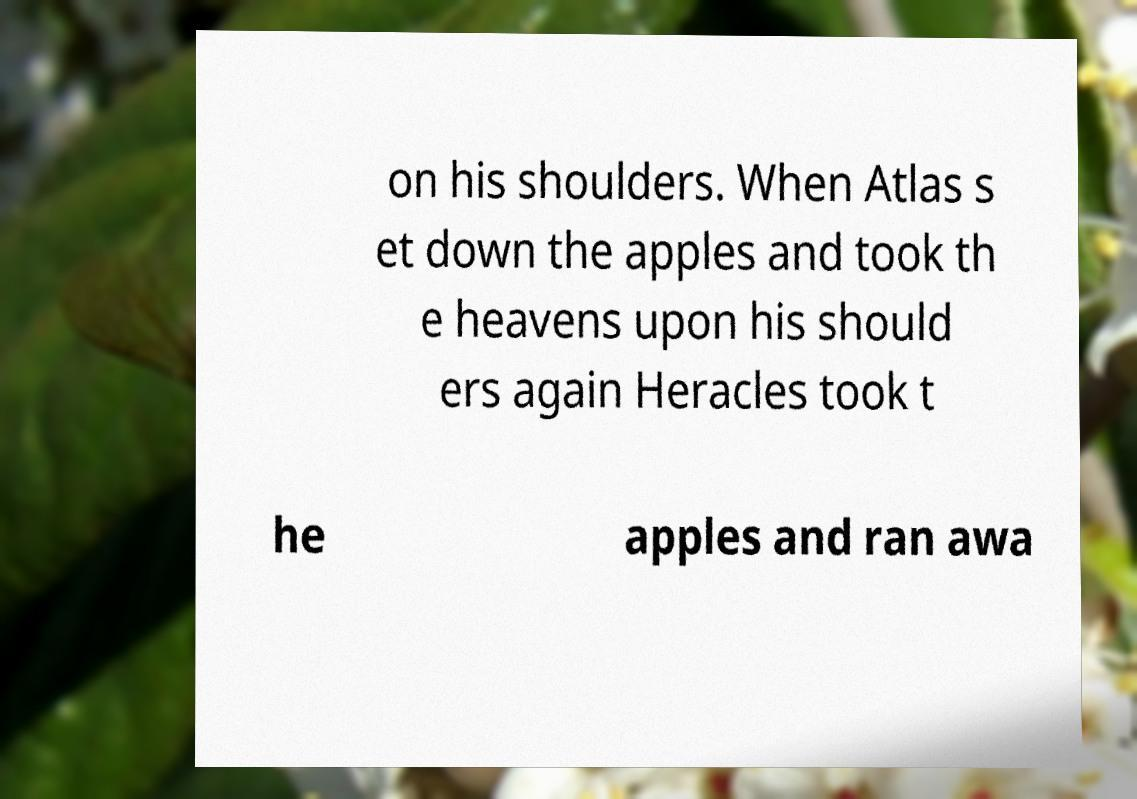Could you extract and type out the text from this image? on his shoulders. When Atlas s et down the apples and took th e heavens upon his should ers again Heracles took t he apples and ran awa 